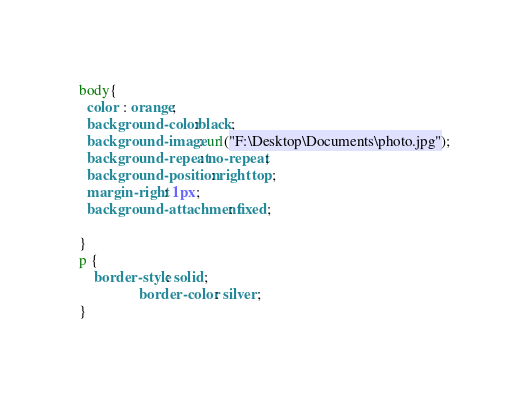<code> <loc_0><loc_0><loc_500><loc_500><_CSS_>body{
  color : orange;
  background-color:black;
  background-image: url("F:\Desktop\Documents\photo.jpg");
  background-repeat: no-repeat;
  background-position: right top;
  margin-right: 1px;
  background-attachment: fixed;

}
p {
	border-style: solid;
               	border-color: silver;
}</code> 